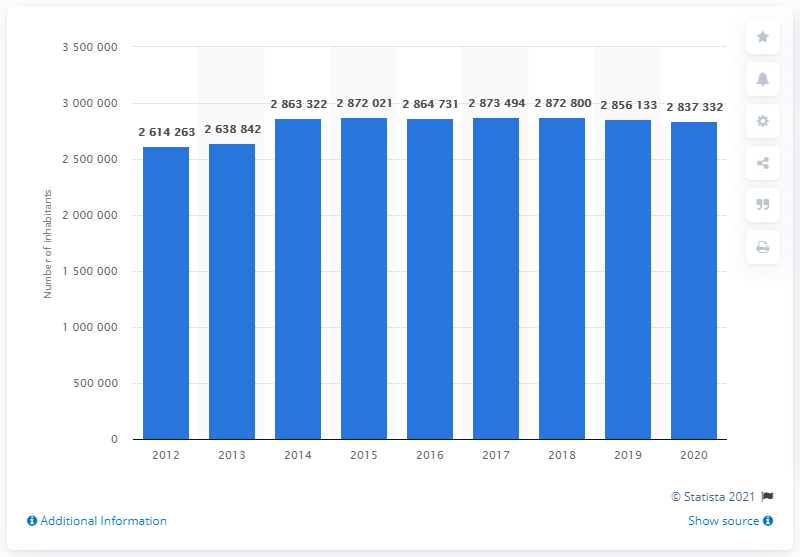How many people lived in Rome in 2012? According to the data depicted in the image, Rome had a population of 2,614,263 in 2012. This figure is part of a larger context showing population trends over several years, highlighting the changes in the city's demography. 